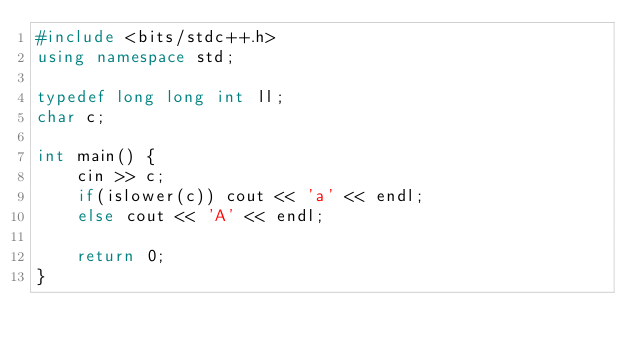<code> <loc_0><loc_0><loc_500><loc_500><_C++_>#include <bits/stdc++.h>
using namespace std;

typedef long long int ll;
char c;

int main() {
    cin >> c;
    if(islower(c)) cout << 'a' << endl;
    else cout << 'A' << endl;

    return 0;
}</code> 